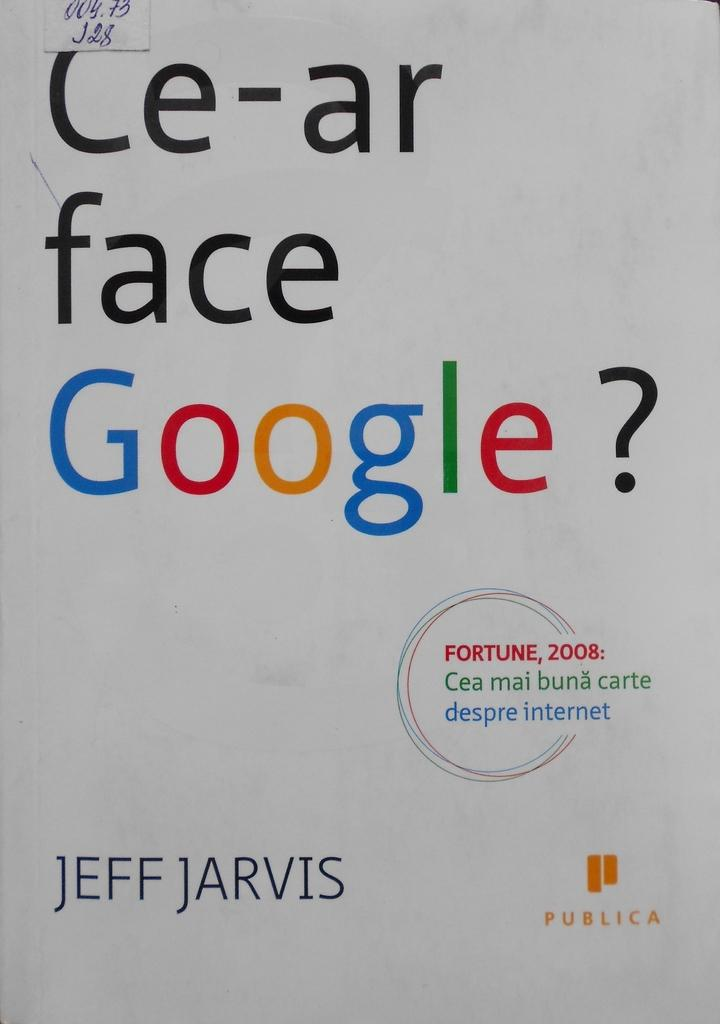Provide a one-sentence caption for the provided image. a book titled Ce-ar face google by jeff jarvis. 